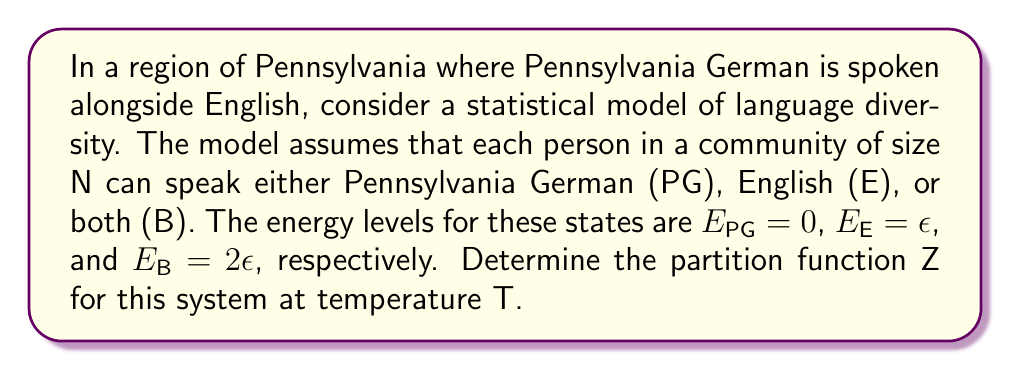Can you solve this math problem? To solve this problem, we'll follow these steps:

1) Recall that the partition function Z is given by the sum of Boltzmann factors over all possible states:

   $$Z = \sum_i g_i e^{-\beta E_i}$$

   where $g_i$ is the degeneracy of state i, $E_i$ is the energy of state i, and $\beta = \frac{1}{k_B T}$.

2) In our model, we have three states (PG, E, B) with their respective energies. The degeneracy for each state is N, as each person can be in any of these states.

3) Let's calculate the Boltzmann factor for each state:
   
   For PG: $e^{-\beta E_{PG}} = e^{-\beta \cdot 0} = 1$
   
   For E: $e^{-\beta E_E} = e^{-\beta \epsilon}$
   
   For B: $e^{-\beta E_B} = e^{-\beta 2\epsilon} = (e^{-\beta \epsilon})^2$

4) Now, we can write our partition function:

   $$Z = N(1 + e^{-\beta \epsilon} + e^{-2\beta \epsilon})$$

5) To simplify, let's substitute $x = e^{-\beta \epsilon}$:

   $$Z = N(1 + x + x^2)$$

This is our final expression for the partition function.
Answer: $Z = N(1 + e^{-\beta \epsilon} + e^{-2\beta \epsilon})$ 